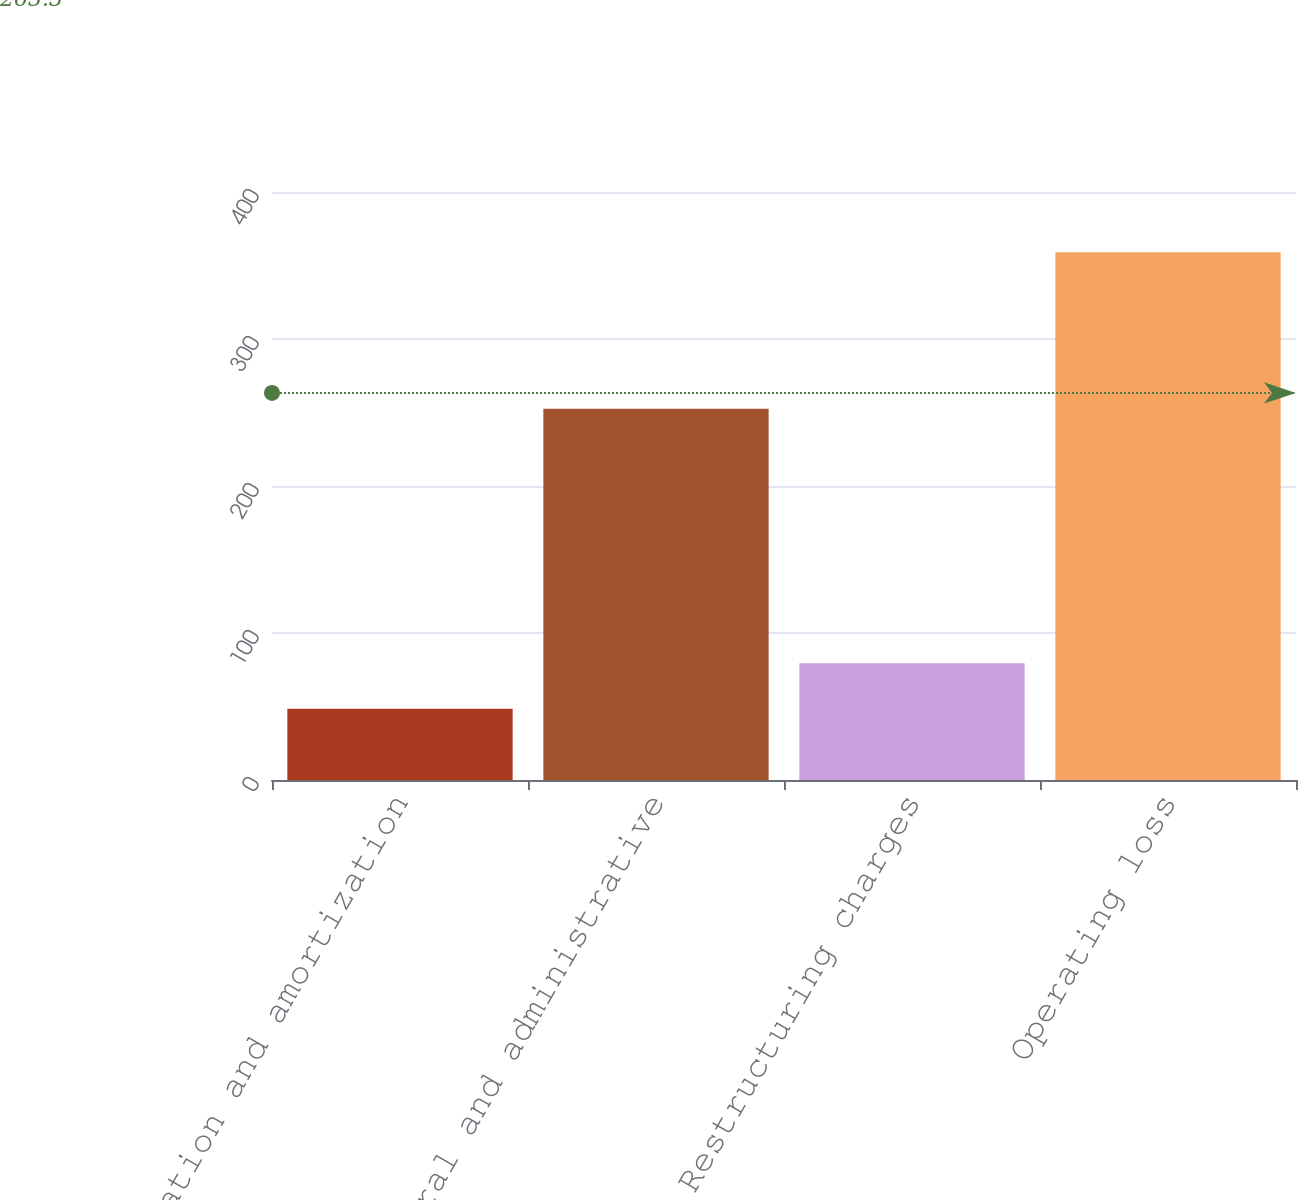<chart> <loc_0><loc_0><loc_500><loc_500><bar_chart><fcel>Depreciation and amortization<fcel>General and administrative<fcel>Restructuring charges<fcel>Operating loss<nl><fcel>48.4<fcel>252.5<fcel>79.46<fcel>359<nl></chart> 